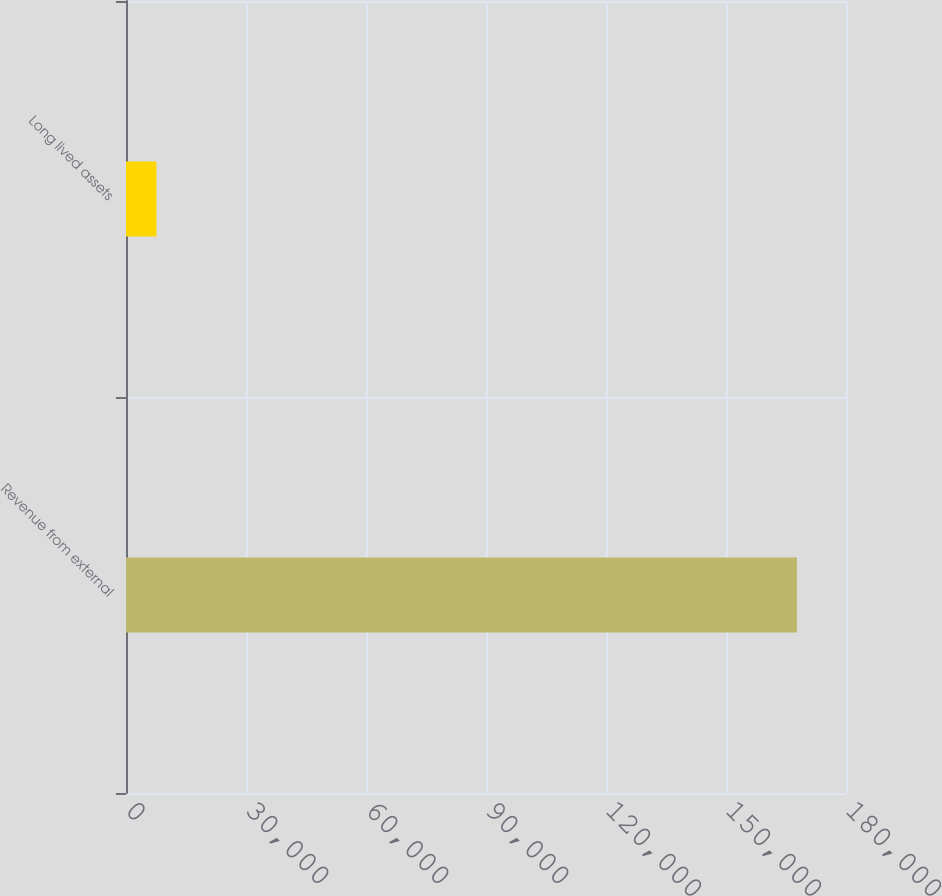Convert chart to OTSL. <chart><loc_0><loc_0><loc_500><loc_500><bar_chart><fcel>Revenue from external<fcel>Long lived assets<nl><fcel>167733<fcel>7607<nl></chart> 